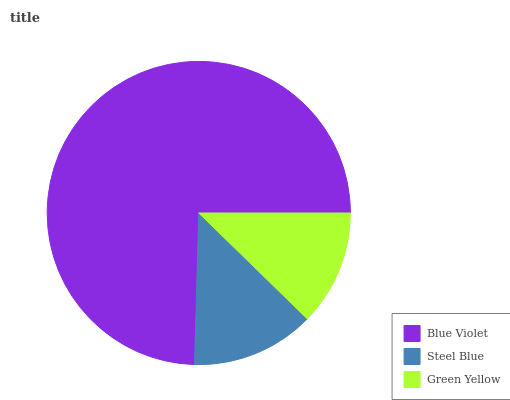Is Green Yellow the minimum?
Answer yes or no. Yes. Is Blue Violet the maximum?
Answer yes or no. Yes. Is Steel Blue the minimum?
Answer yes or no. No. Is Steel Blue the maximum?
Answer yes or no. No. Is Blue Violet greater than Steel Blue?
Answer yes or no. Yes. Is Steel Blue less than Blue Violet?
Answer yes or no. Yes. Is Steel Blue greater than Blue Violet?
Answer yes or no. No. Is Blue Violet less than Steel Blue?
Answer yes or no. No. Is Steel Blue the high median?
Answer yes or no. Yes. Is Steel Blue the low median?
Answer yes or no. Yes. Is Green Yellow the high median?
Answer yes or no. No. Is Blue Violet the low median?
Answer yes or no. No. 